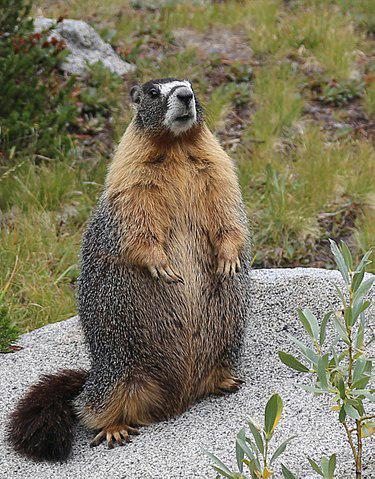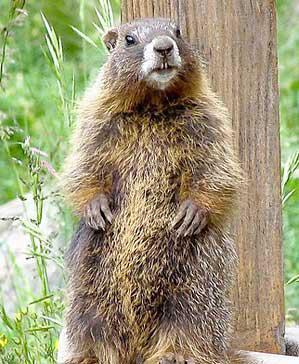The first image is the image on the left, the second image is the image on the right. Analyze the images presented: Is the assertion "There are two marmots standing up on their hind legs" valid? Answer yes or no. Yes. 